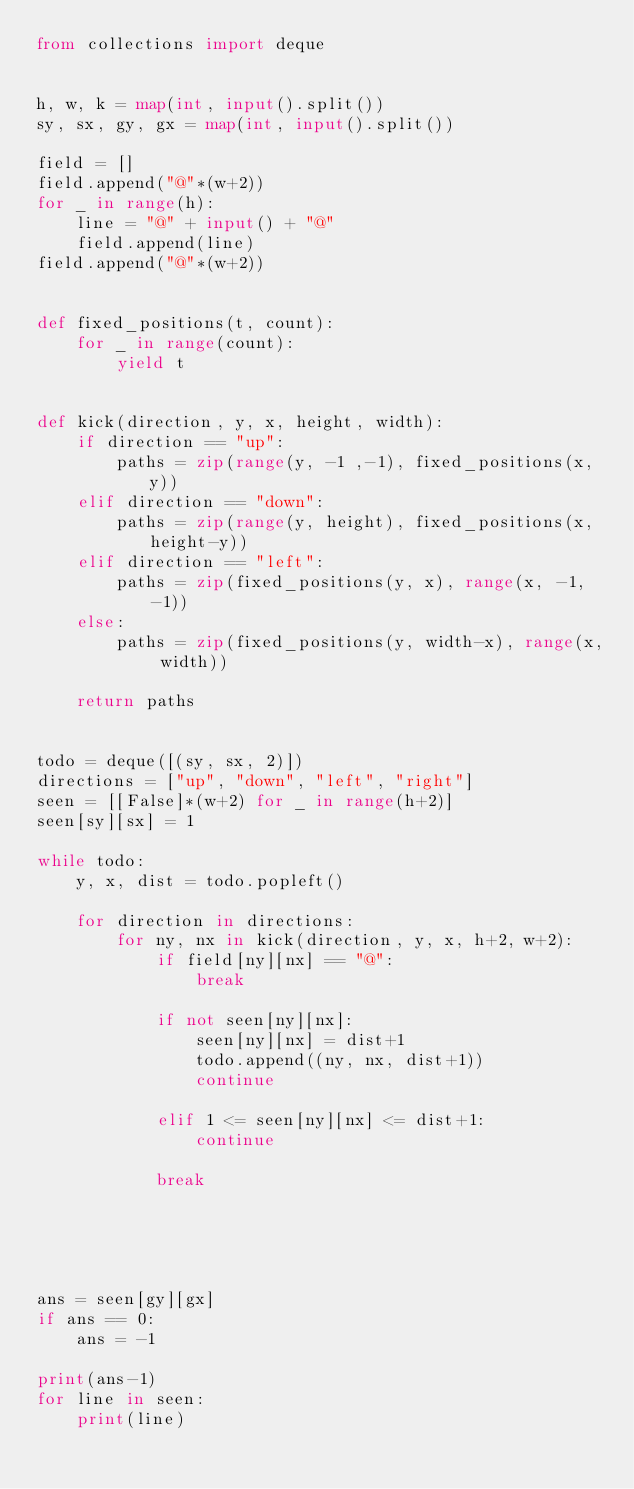Convert code to text. <code><loc_0><loc_0><loc_500><loc_500><_Python_>from collections import deque


h, w, k = map(int, input().split())
sy, sx, gy, gx = map(int, input().split())

field = []
field.append("@"*(w+2))
for _ in range(h):
    line = "@" + input() + "@"
    field.append(line)
field.append("@"*(w+2))


def fixed_positions(t, count):
    for _ in range(count):
        yield t


def kick(direction, y, x, height, width):
    if direction == "up":
        paths = zip(range(y, -1 ,-1), fixed_positions(x, y))
    elif direction == "down":
        paths = zip(range(y, height), fixed_positions(x, height-y))
    elif direction == "left":
        paths = zip(fixed_positions(y, x), range(x, -1, -1))
    else:
        paths = zip(fixed_positions(y, width-x), range(x, width))
    
    return paths


todo = deque([(sy, sx, 2)])
directions = ["up", "down", "left", "right"]
seen = [[False]*(w+2) for _ in range(h+2)]
seen[sy][sx] = 1

while todo:
    y, x, dist = todo.popleft()

    for direction in directions:
        for ny, nx in kick(direction, y, x, h+2, w+2):
            if field[ny][nx] == "@":
                break
            
            if not seen[ny][nx]:
                seen[ny][nx] = dist+1
                todo.append((ny, nx, dist+1))
                continue
                
            elif 1 <= seen[ny][nx] <= dist+1:
                continue
            
            break

            



ans = seen[gy][gx]
if ans == 0:
    ans = -1

print(ans-1)
for line in seen:
    print(line)</code> 